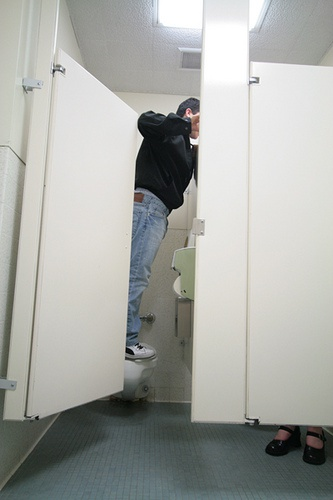Describe the objects in this image and their specific colors. I can see people in darkgray, black, and gray tones, people in darkgray, black, brown, and maroon tones, and toilet in darkgray, gray, and black tones in this image. 